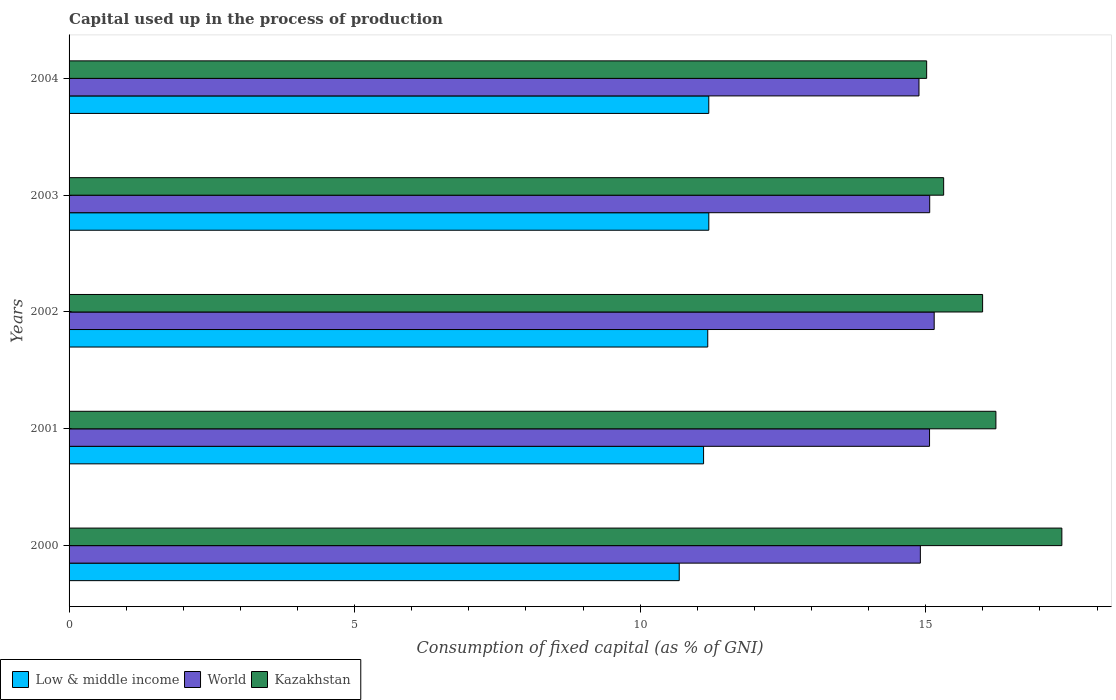How many different coloured bars are there?
Offer a very short reply. 3. Are the number of bars per tick equal to the number of legend labels?
Make the answer very short. Yes. How many bars are there on the 5th tick from the bottom?
Your response must be concise. 3. In how many cases, is the number of bars for a given year not equal to the number of legend labels?
Offer a terse response. 0. What is the capital used up in the process of production in World in 2003?
Provide a short and direct response. 15.07. Across all years, what is the maximum capital used up in the process of production in Kazakhstan?
Your answer should be very brief. 17.38. Across all years, what is the minimum capital used up in the process of production in Low & middle income?
Offer a terse response. 10.68. In which year was the capital used up in the process of production in Kazakhstan maximum?
Offer a very short reply. 2000. What is the total capital used up in the process of production in Low & middle income in the graph?
Give a very brief answer. 55.38. What is the difference between the capital used up in the process of production in Kazakhstan in 2002 and that in 2004?
Make the answer very short. 0.98. What is the difference between the capital used up in the process of production in Low & middle income in 2000 and the capital used up in the process of production in World in 2001?
Offer a terse response. -4.38. What is the average capital used up in the process of production in Kazakhstan per year?
Provide a succinct answer. 15.99. In the year 2000, what is the difference between the capital used up in the process of production in Low & middle income and capital used up in the process of production in Kazakhstan?
Provide a succinct answer. -6.7. In how many years, is the capital used up in the process of production in Kazakhstan greater than 3 %?
Your answer should be compact. 5. What is the ratio of the capital used up in the process of production in Kazakhstan in 2001 to that in 2004?
Provide a short and direct response. 1.08. Is the difference between the capital used up in the process of production in Low & middle income in 2001 and 2003 greater than the difference between the capital used up in the process of production in Kazakhstan in 2001 and 2003?
Your response must be concise. No. What is the difference between the highest and the second highest capital used up in the process of production in Low & middle income?
Keep it short and to the point. 0. What is the difference between the highest and the lowest capital used up in the process of production in Low & middle income?
Your answer should be compact. 0.52. In how many years, is the capital used up in the process of production in Low & middle income greater than the average capital used up in the process of production in Low & middle income taken over all years?
Keep it short and to the point. 4. What does the 3rd bar from the top in 2004 represents?
Make the answer very short. Low & middle income. What does the 2nd bar from the bottom in 2001 represents?
Provide a short and direct response. World. Are all the bars in the graph horizontal?
Keep it short and to the point. Yes. What is the difference between two consecutive major ticks on the X-axis?
Your answer should be very brief. 5. Where does the legend appear in the graph?
Provide a succinct answer. Bottom left. How many legend labels are there?
Offer a terse response. 3. What is the title of the graph?
Ensure brevity in your answer.  Capital used up in the process of production. What is the label or title of the X-axis?
Your answer should be very brief. Consumption of fixed capital (as % of GNI). What is the label or title of the Y-axis?
Keep it short and to the point. Years. What is the Consumption of fixed capital (as % of GNI) of Low & middle income in 2000?
Ensure brevity in your answer.  10.68. What is the Consumption of fixed capital (as % of GNI) in World in 2000?
Ensure brevity in your answer.  14.91. What is the Consumption of fixed capital (as % of GNI) of Kazakhstan in 2000?
Offer a terse response. 17.38. What is the Consumption of fixed capital (as % of GNI) in Low & middle income in 2001?
Offer a very short reply. 11.11. What is the Consumption of fixed capital (as % of GNI) in World in 2001?
Your response must be concise. 15.07. What is the Consumption of fixed capital (as % of GNI) in Kazakhstan in 2001?
Keep it short and to the point. 16.23. What is the Consumption of fixed capital (as % of GNI) of Low & middle income in 2002?
Your response must be concise. 11.18. What is the Consumption of fixed capital (as % of GNI) of World in 2002?
Provide a succinct answer. 15.15. What is the Consumption of fixed capital (as % of GNI) in Kazakhstan in 2002?
Your answer should be compact. 16. What is the Consumption of fixed capital (as % of GNI) in Low & middle income in 2003?
Offer a very short reply. 11.2. What is the Consumption of fixed capital (as % of GNI) in World in 2003?
Offer a terse response. 15.07. What is the Consumption of fixed capital (as % of GNI) of Kazakhstan in 2003?
Ensure brevity in your answer.  15.31. What is the Consumption of fixed capital (as % of GNI) of Low & middle income in 2004?
Make the answer very short. 11.2. What is the Consumption of fixed capital (as % of GNI) of World in 2004?
Provide a succinct answer. 14.88. What is the Consumption of fixed capital (as % of GNI) in Kazakhstan in 2004?
Your answer should be compact. 15.02. Across all years, what is the maximum Consumption of fixed capital (as % of GNI) of Low & middle income?
Provide a succinct answer. 11.2. Across all years, what is the maximum Consumption of fixed capital (as % of GNI) in World?
Give a very brief answer. 15.15. Across all years, what is the maximum Consumption of fixed capital (as % of GNI) in Kazakhstan?
Provide a succinct answer. 17.38. Across all years, what is the minimum Consumption of fixed capital (as % of GNI) of Low & middle income?
Your answer should be compact. 10.68. Across all years, what is the minimum Consumption of fixed capital (as % of GNI) of World?
Give a very brief answer. 14.88. Across all years, what is the minimum Consumption of fixed capital (as % of GNI) of Kazakhstan?
Provide a succinct answer. 15.02. What is the total Consumption of fixed capital (as % of GNI) in Low & middle income in the graph?
Your answer should be compact. 55.38. What is the total Consumption of fixed capital (as % of GNI) in World in the graph?
Offer a terse response. 75.08. What is the total Consumption of fixed capital (as % of GNI) in Kazakhstan in the graph?
Your response must be concise. 79.94. What is the difference between the Consumption of fixed capital (as % of GNI) in Low & middle income in 2000 and that in 2001?
Provide a succinct answer. -0.43. What is the difference between the Consumption of fixed capital (as % of GNI) of World in 2000 and that in 2001?
Keep it short and to the point. -0.16. What is the difference between the Consumption of fixed capital (as % of GNI) in Kazakhstan in 2000 and that in 2001?
Make the answer very short. 1.15. What is the difference between the Consumption of fixed capital (as % of GNI) in Low & middle income in 2000 and that in 2002?
Make the answer very short. -0.5. What is the difference between the Consumption of fixed capital (as % of GNI) in World in 2000 and that in 2002?
Ensure brevity in your answer.  -0.24. What is the difference between the Consumption of fixed capital (as % of GNI) in Kazakhstan in 2000 and that in 2002?
Ensure brevity in your answer.  1.39. What is the difference between the Consumption of fixed capital (as % of GNI) of Low & middle income in 2000 and that in 2003?
Give a very brief answer. -0.52. What is the difference between the Consumption of fixed capital (as % of GNI) in World in 2000 and that in 2003?
Provide a short and direct response. -0.16. What is the difference between the Consumption of fixed capital (as % of GNI) in Kazakhstan in 2000 and that in 2003?
Offer a terse response. 2.07. What is the difference between the Consumption of fixed capital (as % of GNI) of Low & middle income in 2000 and that in 2004?
Your response must be concise. -0.52. What is the difference between the Consumption of fixed capital (as % of GNI) in World in 2000 and that in 2004?
Give a very brief answer. 0.02. What is the difference between the Consumption of fixed capital (as % of GNI) in Kazakhstan in 2000 and that in 2004?
Keep it short and to the point. 2.37. What is the difference between the Consumption of fixed capital (as % of GNI) in Low & middle income in 2001 and that in 2002?
Provide a short and direct response. -0.07. What is the difference between the Consumption of fixed capital (as % of GNI) in World in 2001 and that in 2002?
Keep it short and to the point. -0.08. What is the difference between the Consumption of fixed capital (as % of GNI) of Kazakhstan in 2001 and that in 2002?
Your answer should be very brief. 0.23. What is the difference between the Consumption of fixed capital (as % of GNI) in Low & middle income in 2001 and that in 2003?
Give a very brief answer. -0.09. What is the difference between the Consumption of fixed capital (as % of GNI) of World in 2001 and that in 2003?
Provide a short and direct response. -0. What is the difference between the Consumption of fixed capital (as % of GNI) of Kazakhstan in 2001 and that in 2003?
Your response must be concise. 0.92. What is the difference between the Consumption of fixed capital (as % of GNI) in Low & middle income in 2001 and that in 2004?
Your answer should be very brief. -0.09. What is the difference between the Consumption of fixed capital (as % of GNI) in World in 2001 and that in 2004?
Your response must be concise. 0.18. What is the difference between the Consumption of fixed capital (as % of GNI) of Kazakhstan in 2001 and that in 2004?
Your answer should be very brief. 1.21. What is the difference between the Consumption of fixed capital (as % of GNI) of Low & middle income in 2002 and that in 2003?
Give a very brief answer. -0.02. What is the difference between the Consumption of fixed capital (as % of GNI) of World in 2002 and that in 2003?
Your answer should be compact. 0.08. What is the difference between the Consumption of fixed capital (as % of GNI) of Kazakhstan in 2002 and that in 2003?
Your response must be concise. 0.68. What is the difference between the Consumption of fixed capital (as % of GNI) in Low & middle income in 2002 and that in 2004?
Offer a terse response. -0.02. What is the difference between the Consumption of fixed capital (as % of GNI) in World in 2002 and that in 2004?
Provide a short and direct response. 0.27. What is the difference between the Consumption of fixed capital (as % of GNI) of Kazakhstan in 2002 and that in 2004?
Provide a succinct answer. 0.98. What is the difference between the Consumption of fixed capital (as % of GNI) of Low & middle income in 2003 and that in 2004?
Keep it short and to the point. 0. What is the difference between the Consumption of fixed capital (as % of GNI) of World in 2003 and that in 2004?
Ensure brevity in your answer.  0.19. What is the difference between the Consumption of fixed capital (as % of GNI) of Kazakhstan in 2003 and that in 2004?
Your answer should be compact. 0.3. What is the difference between the Consumption of fixed capital (as % of GNI) of Low & middle income in 2000 and the Consumption of fixed capital (as % of GNI) of World in 2001?
Your response must be concise. -4.38. What is the difference between the Consumption of fixed capital (as % of GNI) of Low & middle income in 2000 and the Consumption of fixed capital (as % of GNI) of Kazakhstan in 2001?
Make the answer very short. -5.54. What is the difference between the Consumption of fixed capital (as % of GNI) in World in 2000 and the Consumption of fixed capital (as % of GNI) in Kazakhstan in 2001?
Your response must be concise. -1.32. What is the difference between the Consumption of fixed capital (as % of GNI) of Low & middle income in 2000 and the Consumption of fixed capital (as % of GNI) of World in 2002?
Give a very brief answer. -4.46. What is the difference between the Consumption of fixed capital (as % of GNI) in Low & middle income in 2000 and the Consumption of fixed capital (as % of GNI) in Kazakhstan in 2002?
Your answer should be very brief. -5.31. What is the difference between the Consumption of fixed capital (as % of GNI) in World in 2000 and the Consumption of fixed capital (as % of GNI) in Kazakhstan in 2002?
Make the answer very short. -1.09. What is the difference between the Consumption of fixed capital (as % of GNI) in Low & middle income in 2000 and the Consumption of fixed capital (as % of GNI) in World in 2003?
Provide a succinct answer. -4.39. What is the difference between the Consumption of fixed capital (as % of GNI) in Low & middle income in 2000 and the Consumption of fixed capital (as % of GNI) in Kazakhstan in 2003?
Offer a very short reply. -4.63. What is the difference between the Consumption of fixed capital (as % of GNI) in World in 2000 and the Consumption of fixed capital (as % of GNI) in Kazakhstan in 2003?
Provide a succinct answer. -0.41. What is the difference between the Consumption of fixed capital (as % of GNI) of Low & middle income in 2000 and the Consumption of fixed capital (as % of GNI) of World in 2004?
Keep it short and to the point. -4.2. What is the difference between the Consumption of fixed capital (as % of GNI) in Low & middle income in 2000 and the Consumption of fixed capital (as % of GNI) in Kazakhstan in 2004?
Give a very brief answer. -4.33. What is the difference between the Consumption of fixed capital (as % of GNI) of World in 2000 and the Consumption of fixed capital (as % of GNI) of Kazakhstan in 2004?
Keep it short and to the point. -0.11. What is the difference between the Consumption of fixed capital (as % of GNI) in Low & middle income in 2001 and the Consumption of fixed capital (as % of GNI) in World in 2002?
Offer a terse response. -4.04. What is the difference between the Consumption of fixed capital (as % of GNI) of Low & middle income in 2001 and the Consumption of fixed capital (as % of GNI) of Kazakhstan in 2002?
Give a very brief answer. -4.89. What is the difference between the Consumption of fixed capital (as % of GNI) in World in 2001 and the Consumption of fixed capital (as % of GNI) in Kazakhstan in 2002?
Ensure brevity in your answer.  -0.93. What is the difference between the Consumption of fixed capital (as % of GNI) in Low & middle income in 2001 and the Consumption of fixed capital (as % of GNI) in World in 2003?
Offer a very short reply. -3.96. What is the difference between the Consumption of fixed capital (as % of GNI) in Low & middle income in 2001 and the Consumption of fixed capital (as % of GNI) in Kazakhstan in 2003?
Provide a short and direct response. -4.2. What is the difference between the Consumption of fixed capital (as % of GNI) of World in 2001 and the Consumption of fixed capital (as % of GNI) of Kazakhstan in 2003?
Your response must be concise. -0.25. What is the difference between the Consumption of fixed capital (as % of GNI) of Low & middle income in 2001 and the Consumption of fixed capital (as % of GNI) of World in 2004?
Your answer should be compact. -3.77. What is the difference between the Consumption of fixed capital (as % of GNI) in Low & middle income in 2001 and the Consumption of fixed capital (as % of GNI) in Kazakhstan in 2004?
Your answer should be compact. -3.91. What is the difference between the Consumption of fixed capital (as % of GNI) of World in 2001 and the Consumption of fixed capital (as % of GNI) of Kazakhstan in 2004?
Ensure brevity in your answer.  0.05. What is the difference between the Consumption of fixed capital (as % of GNI) in Low & middle income in 2002 and the Consumption of fixed capital (as % of GNI) in World in 2003?
Keep it short and to the point. -3.89. What is the difference between the Consumption of fixed capital (as % of GNI) in Low & middle income in 2002 and the Consumption of fixed capital (as % of GNI) in Kazakhstan in 2003?
Offer a very short reply. -4.13. What is the difference between the Consumption of fixed capital (as % of GNI) of World in 2002 and the Consumption of fixed capital (as % of GNI) of Kazakhstan in 2003?
Provide a succinct answer. -0.17. What is the difference between the Consumption of fixed capital (as % of GNI) of Low & middle income in 2002 and the Consumption of fixed capital (as % of GNI) of World in 2004?
Your answer should be very brief. -3.7. What is the difference between the Consumption of fixed capital (as % of GNI) of Low & middle income in 2002 and the Consumption of fixed capital (as % of GNI) of Kazakhstan in 2004?
Offer a very short reply. -3.83. What is the difference between the Consumption of fixed capital (as % of GNI) in World in 2002 and the Consumption of fixed capital (as % of GNI) in Kazakhstan in 2004?
Ensure brevity in your answer.  0.13. What is the difference between the Consumption of fixed capital (as % of GNI) in Low & middle income in 2003 and the Consumption of fixed capital (as % of GNI) in World in 2004?
Your response must be concise. -3.68. What is the difference between the Consumption of fixed capital (as % of GNI) of Low & middle income in 2003 and the Consumption of fixed capital (as % of GNI) of Kazakhstan in 2004?
Keep it short and to the point. -3.81. What is the difference between the Consumption of fixed capital (as % of GNI) in World in 2003 and the Consumption of fixed capital (as % of GNI) in Kazakhstan in 2004?
Make the answer very short. 0.05. What is the average Consumption of fixed capital (as % of GNI) of Low & middle income per year?
Provide a succinct answer. 11.08. What is the average Consumption of fixed capital (as % of GNI) of World per year?
Your answer should be very brief. 15.02. What is the average Consumption of fixed capital (as % of GNI) in Kazakhstan per year?
Make the answer very short. 15.99. In the year 2000, what is the difference between the Consumption of fixed capital (as % of GNI) of Low & middle income and Consumption of fixed capital (as % of GNI) of World?
Make the answer very short. -4.22. In the year 2000, what is the difference between the Consumption of fixed capital (as % of GNI) of Low & middle income and Consumption of fixed capital (as % of GNI) of Kazakhstan?
Provide a short and direct response. -6.7. In the year 2000, what is the difference between the Consumption of fixed capital (as % of GNI) in World and Consumption of fixed capital (as % of GNI) in Kazakhstan?
Your answer should be compact. -2.48. In the year 2001, what is the difference between the Consumption of fixed capital (as % of GNI) of Low & middle income and Consumption of fixed capital (as % of GNI) of World?
Your answer should be compact. -3.96. In the year 2001, what is the difference between the Consumption of fixed capital (as % of GNI) of Low & middle income and Consumption of fixed capital (as % of GNI) of Kazakhstan?
Ensure brevity in your answer.  -5.12. In the year 2001, what is the difference between the Consumption of fixed capital (as % of GNI) in World and Consumption of fixed capital (as % of GNI) in Kazakhstan?
Offer a terse response. -1.16. In the year 2002, what is the difference between the Consumption of fixed capital (as % of GNI) in Low & middle income and Consumption of fixed capital (as % of GNI) in World?
Your answer should be very brief. -3.96. In the year 2002, what is the difference between the Consumption of fixed capital (as % of GNI) of Low & middle income and Consumption of fixed capital (as % of GNI) of Kazakhstan?
Your answer should be very brief. -4.81. In the year 2002, what is the difference between the Consumption of fixed capital (as % of GNI) of World and Consumption of fixed capital (as % of GNI) of Kazakhstan?
Provide a succinct answer. -0.85. In the year 2003, what is the difference between the Consumption of fixed capital (as % of GNI) in Low & middle income and Consumption of fixed capital (as % of GNI) in World?
Make the answer very short. -3.87. In the year 2003, what is the difference between the Consumption of fixed capital (as % of GNI) in Low & middle income and Consumption of fixed capital (as % of GNI) in Kazakhstan?
Keep it short and to the point. -4.11. In the year 2003, what is the difference between the Consumption of fixed capital (as % of GNI) in World and Consumption of fixed capital (as % of GNI) in Kazakhstan?
Offer a terse response. -0.24. In the year 2004, what is the difference between the Consumption of fixed capital (as % of GNI) in Low & middle income and Consumption of fixed capital (as % of GNI) in World?
Give a very brief answer. -3.68. In the year 2004, what is the difference between the Consumption of fixed capital (as % of GNI) of Low & middle income and Consumption of fixed capital (as % of GNI) of Kazakhstan?
Keep it short and to the point. -3.82. In the year 2004, what is the difference between the Consumption of fixed capital (as % of GNI) of World and Consumption of fixed capital (as % of GNI) of Kazakhstan?
Ensure brevity in your answer.  -0.13. What is the ratio of the Consumption of fixed capital (as % of GNI) in Low & middle income in 2000 to that in 2001?
Provide a succinct answer. 0.96. What is the ratio of the Consumption of fixed capital (as % of GNI) in World in 2000 to that in 2001?
Provide a succinct answer. 0.99. What is the ratio of the Consumption of fixed capital (as % of GNI) of Kazakhstan in 2000 to that in 2001?
Offer a very short reply. 1.07. What is the ratio of the Consumption of fixed capital (as % of GNI) in Low & middle income in 2000 to that in 2002?
Ensure brevity in your answer.  0.96. What is the ratio of the Consumption of fixed capital (as % of GNI) of World in 2000 to that in 2002?
Give a very brief answer. 0.98. What is the ratio of the Consumption of fixed capital (as % of GNI) in Kazakhstan in 2000 to that in 2002?
Keep it short and to the point. 1.09. What is the ratio of the Consumption of fixed capital (as % of GNI) in Low & middle income in 2000 to that in 2003?
Ensure brevity in your answer.  0.95. What is the ratio of the Consumption of fixed capital (as % of GNI) in Kazakhstan in 2000 to that in 2003?
Offer a terse response. 1.14. What is the ratio of the Consumption of fixed capital (as % of GNI) in Low & middle income in 2000 to that in 2004?
Offer a terse response. 0.95. What is the ratio of the Consumption of fixed capital (as % of GNI) in World in 2000 to that in 2004?
Make the answer very short. 1. What is the ratio of the Consumption of fixed capital (as % of GNI) of Kazakhstan in 2000 to that in 2004?
Provide a succinct answer. 1.16. What is the ratio of the Consumption of fixed capital (as % of GNI) of Kazakhstan in 2001 to that in 2002?
Provide a short and direct response. 1.01. What is the ratio of the Consumption of fixed capital (as % of GNI) of Low & middle income in 2001 to that in 2003?
Make the answer very short. 0.99. What is the ratio of the Consumption of fixed capital (as % of GNI) in Kazakhstan in 2001 to that in 2003?
Provide a short and direct response. 1.06. What is the ratio of the Consumption of fixed capital (as % of GNI) in Low & middle income in 2001 to that in 2004?
Provide a short and direct response. 0.99. What is the ratio of the Consumption of fixed capital (as % of GNI) of World in 2001 to that in 2004?
Offer a terse response. 1.01. What is the ratio of the Consumption of fixed capital (as % of GNI) in Kazakhstan in 2001 to that in 2004?
Your answer should be compact. 1.08. What is the ratio of the Consumption of fixed capital (as % of GNI) in Kazakhstan in 2002 to that in 2003?
Your answer should be compact. 1.04. What is the ratio of the Consumption of fixed capital (as % of GNI) of World in 2002 to that in 2004?
Ensure brevity in your answer.  1.02. What is the ratio of the Consumption of fixed capital (as % of GNI) in Kazakhstan in 2002 to that in 2004?
Give a very brief answer. 1.07. What is the ratio of the Consumption of fixed capital (as % of GNI) of Low & middle income in 2003 to that in 2004?
Ensure brevity in your answer.  1. What is the ratio of the Consumption of fixed capital (as % of GNI) in World in 2003 to that in 2004?
Provide a succinct answer. 1.01. What is the ratio of the Consumption of fixed capital (as % of GNI) in Kazakhstan in 2003 to that in 2004?
Provide a short and direct response. 1.02. What is the difference between the highest and the second highest Consumption of fixed capital (as % of GNI) of Low & middle income?
Offer a terse response. 0. What is the difference between the highest and the second highest Consumption of fixed capital (as % of GNI) of World?
Provide a short and direct response. 0.08. What is the difference between the highest and the second highest Consumption of fixed capital (as % of GNI) in Kazakhstan?
Ensure brevity in your answer.  1.15. What is the difference between the highest and the lowest Consumption of fixed capital (as % of GNI) of Low & middle income?
Provide a short and direct response. 0.52. What is the difference between the highest and the lowest Consumption of fixed capital (as % of GNI) of World?
Offer a very short reply. 0.27. What is the difference between the highest and the lowest Consumption of fixed capital (as % of GNI) of Kazakhstan?
Provide a succinct answer. 2.37. 